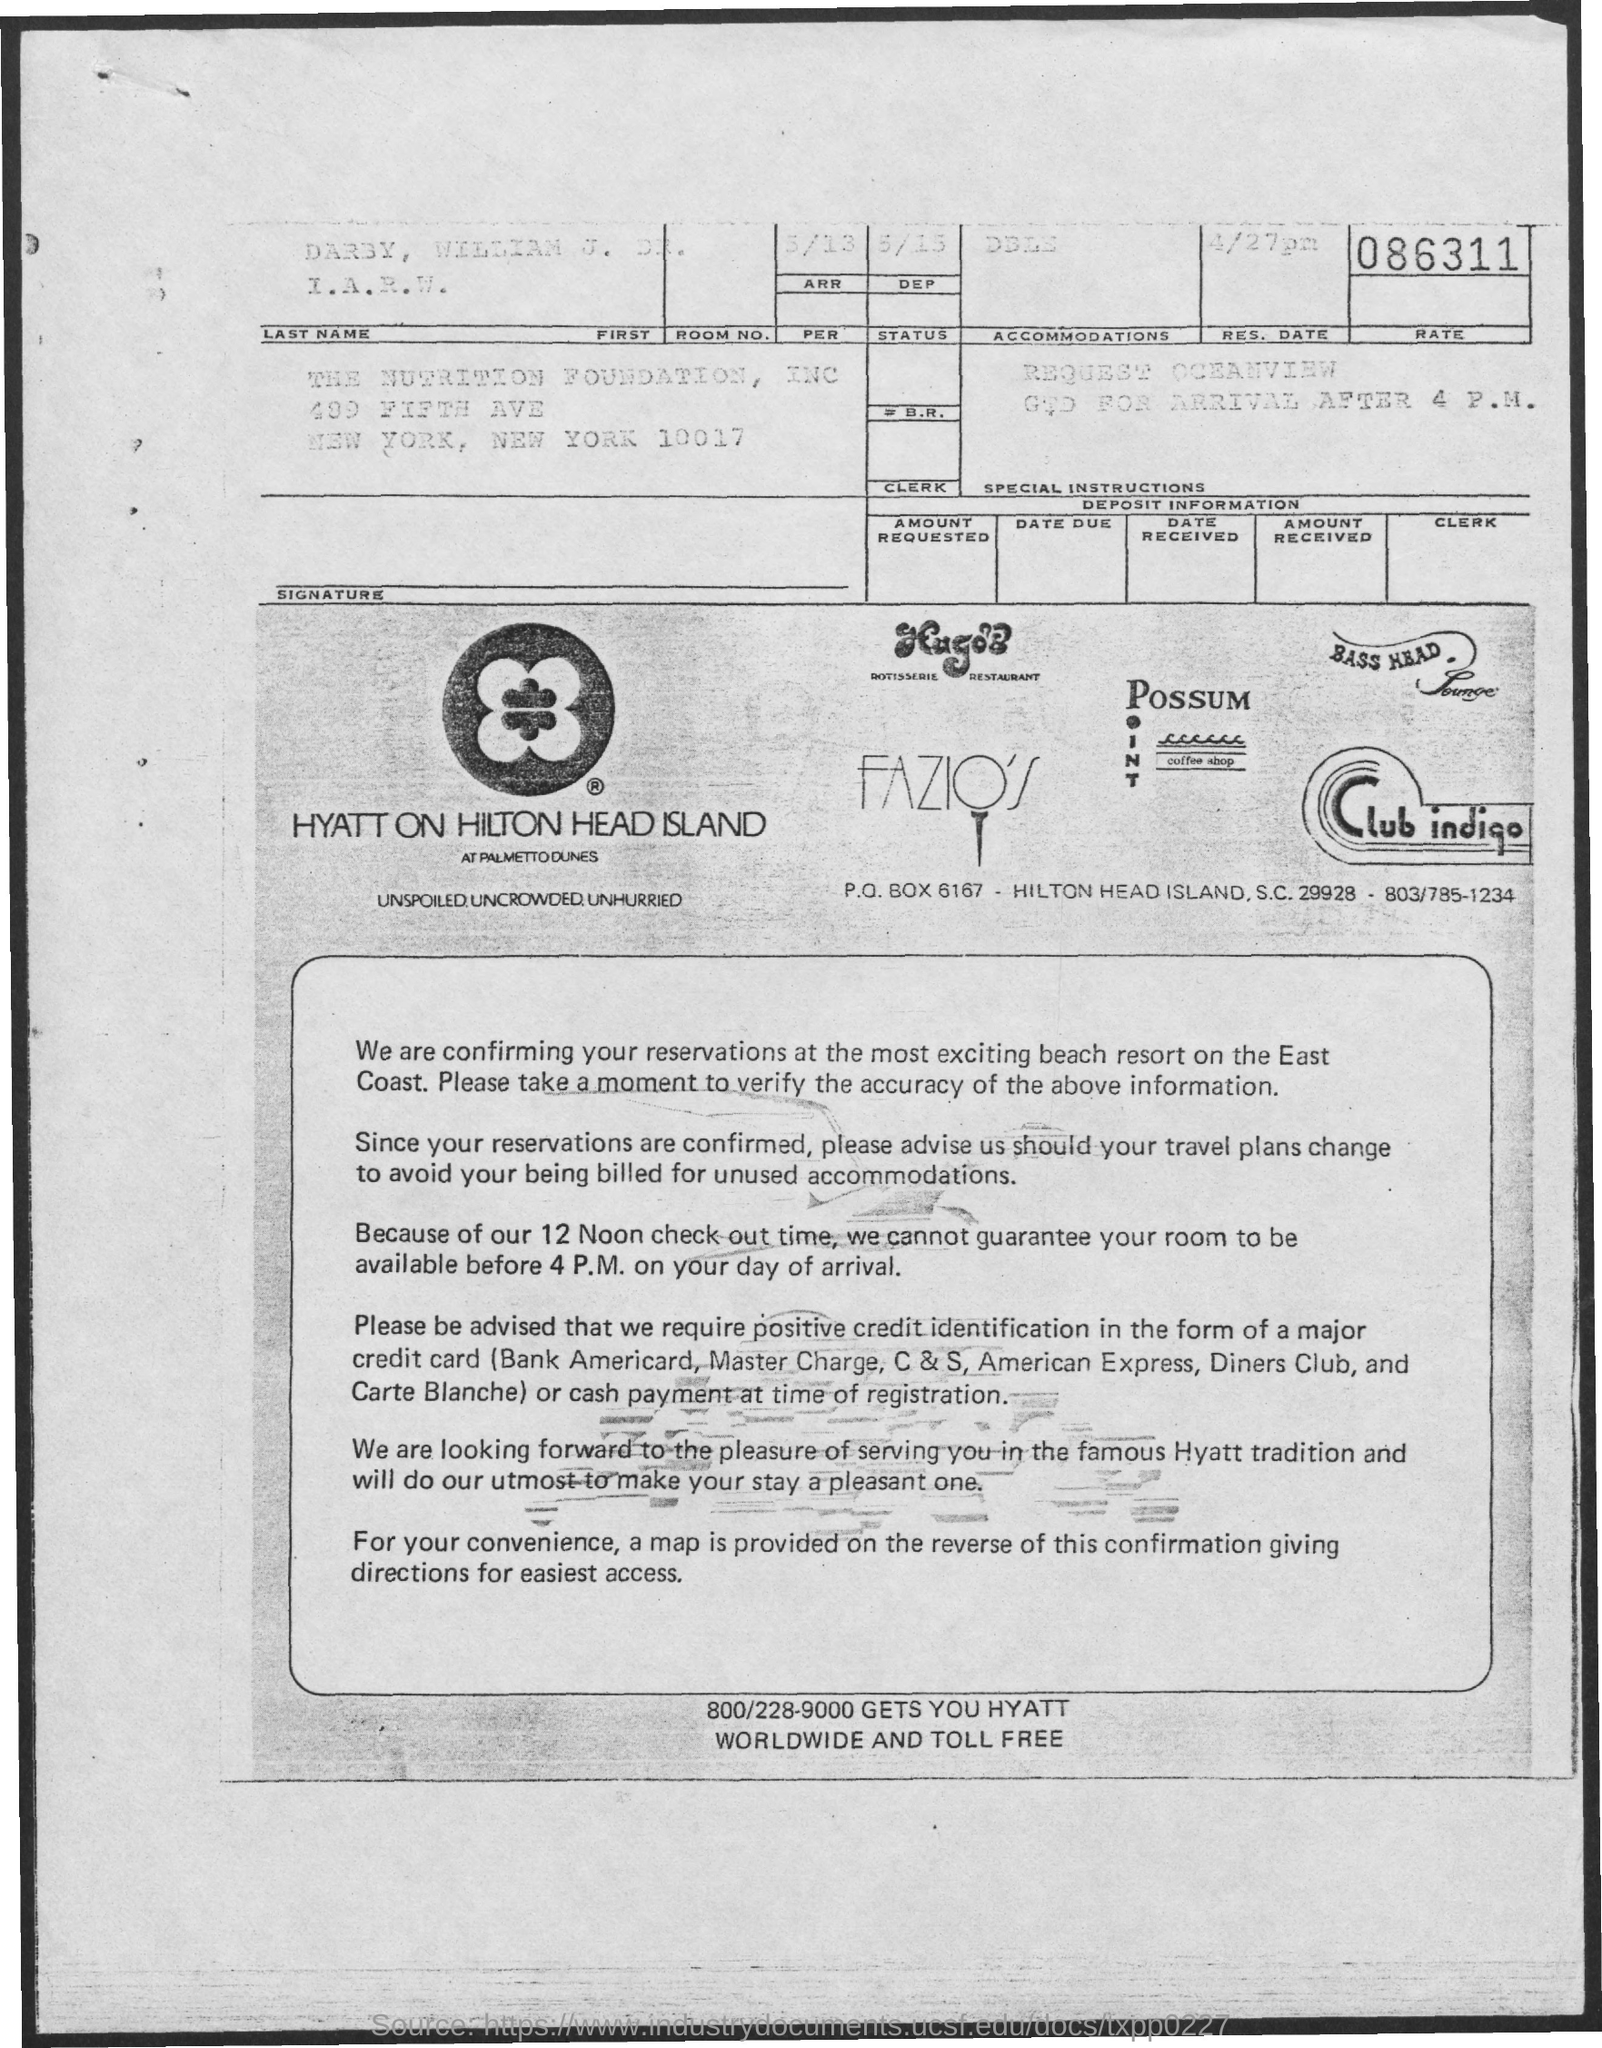Where is the reservations confirmed?
Your response must be concise. Beach resort on the east coast. When is the checkout time?
Your answer should be compact. 12 NOON. 